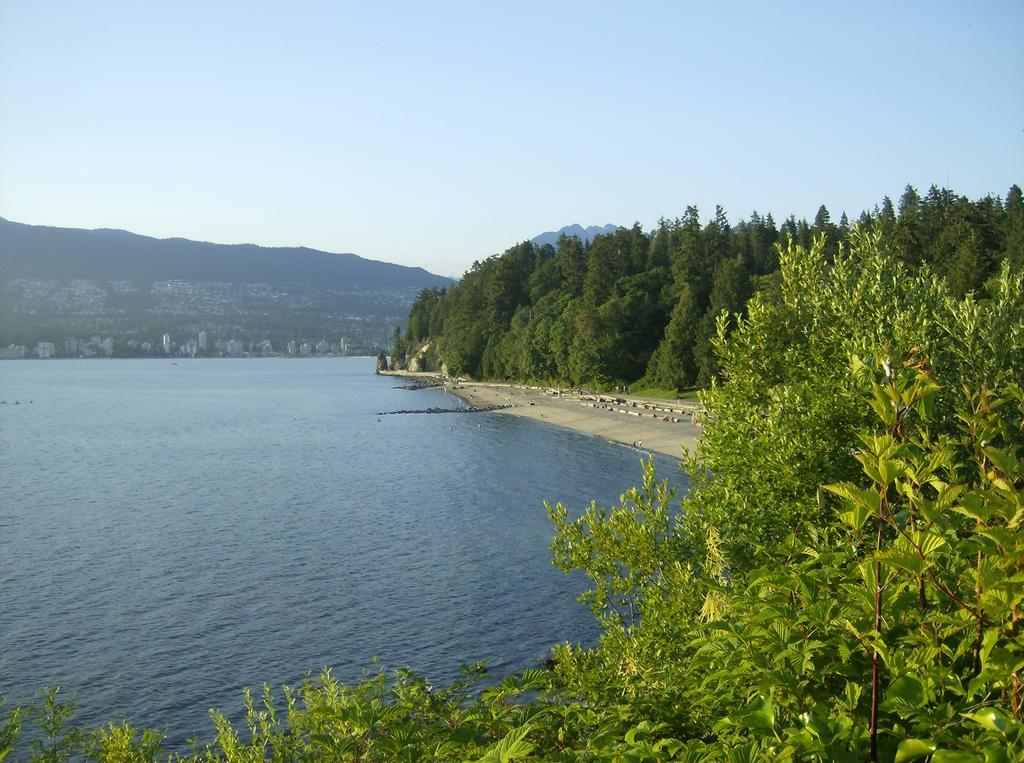What type of natural elements can be seen in the image? There are trees and water visible in the image. What type of geographical feature is present in the image? There are mountains in the image. What can be seen in the background of the image? The sky is visible in the background of the image. Where is the throne located in the image? There is no throne present in the image. Can you describe the cooking utensils used in the image? There are no cooking utensils or any cooking activity depicted in the image. 